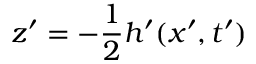<formula> <loc_0><loc_0><loc_500><loc_500>z ^ { \prime } = - \frac { 1 } { 2 } h ^ { \prime } ( x ^ { \prime } , t ^ { \prime } )</formula> 